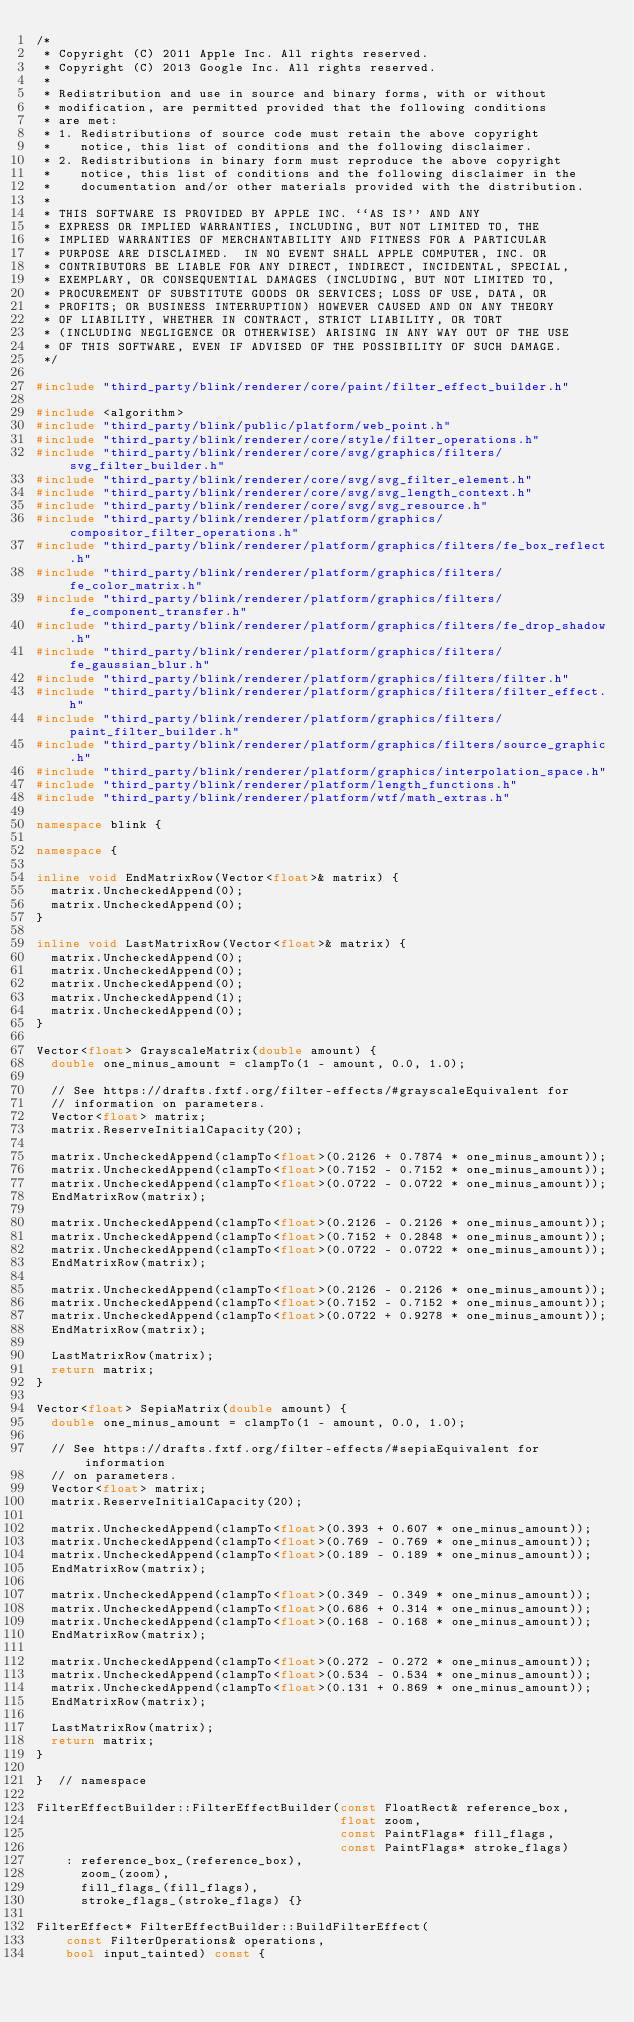<code> <loc_0><loc_0><loc_500><loc_500><_C++_>/*
 * Copyright (C) 2011 Apple Inc. All rights reserved.
 * Copyright (C) 2013 Google Inc. All rights reserved.
 *
 * Redistribution and use in source and binary forms, with or without
 * modification, are permitted provided that the following conditions
 * are met:
 * 1. Redistributions of source code must retain the above copyright
 *    notice, this list of conditions and the following disclaimer.
 * 2. Redistributions in binary form must reproduce the above copyright
 *    notice, this list of conditions and the following disclaimer in the
 *    documentation and/or other materials provided with the distribution.
 *
 * THIS SOFTWARE IS PROVIDED BY APPLE INC. ``AS IS'' AND ANY
 * EXPRESS OR IMPLIED WARRANTIES, INCLUDING, BUT NOT LIMITED TO, THE
 * IMPLIED WARRANTIES OF MERCHANTABILITY AND FITNESS FOR A PARTICULAR
 * PURPOSE ARE DISCLAIMED.  IN NO EVENT SHALL APPLE COMPUTER, INC. OR
 * CONTRIBUTORS BE LIABLE FOR ANY DIRECT, INDIRECT, INCIDENTAL, SPECIAL,
 * EXEMPLARY, OR CONSEQUENTIAL DAMAGES (INCLUDING, BUT NOT LIMITED TO,
 * PROCUREMENT OF SUBSTITUTE GOODS OR SERVICES; LOSS OF USE, DATA, OR
 * PROFITS; OR BUSINESS INTERRUPTION) HOWEVER CAUSED AND ON ANY THEORY
 * OF LIABILITY, WHETHER IN CONTRACT, STRICT LIABILITY, OR TORT
 * (INCLUDING NEGLIGENCE OR OTHERWISE) ARISING IN ANY WAY OUT OF THE USE
 * OF THIS SOFTWARE, EVEN IF ADVISED OF THE POSSIBILITY OF SUCH DAMAGE.
 */

#include "third_party/blink/renderer/core/paint/filter_effect_builder.h"

#include <algorithm>
#include "third_party/blink/public/platform/web_point.h"
#include "third_party/blink/renderer/core/style/filter_operations.h"
#include "third_party/blink/renderer/core/svg/graphics/filters/svg_filter_builder.h"
#include "third_party/blink/renderer/core/svg/svg_filter_element.h"
#include "third_party/blink/renderer/core/svg/svg_length_context.h"
#include "third_party/blink/renderer/core/svg/svg_resource.h"
#include "third_party/blink/renderer/platform/graphics/compositor_filter_operations.h"
#include "third_party/blink/renderer/platform/graphics/filters/fe_box_reflect.h"
#include "third_party/blink/renderer/platform/graphics/filters/fe_color_matrix.h"
#include "third_party/blink/renderer/platform/graphics/filters/fe_component_transfer.h"
#include "third_party/blink/renderer/platform/graphics/filters/fe_drop_shadow.h"
#include "third_party/blink/renderer/platform/graphics/filters/fe_gaussian_blur.h"
#include "third_party/blink/renderer/platform/graphics/filters/filter.h"
#include "third_party/blink/renderer/platform/graphics/filters/filter_effect.h"
#include "third_party/blink/renderer/platform/graphics/filters/paint_filter_builder.h"
#include "third_party/blink/renderer/platform/graphics/filters/source_graphic.h"
#include "third_party/blink/renderer/platform/graphics/interpolation_space.h"
#include "third_party/blink/renderer/platform/length_functions.h"
#include "third_party/blink/renderer/platform/wtf/math_extras.h"

namespace blink {

namespace {

inline void EndMatrixRow(Vector<float>& matrix) {
  matrix.UncheckedAppend(0);
  matrix.UncheckedAppend(0);
}

inline void LastMatrixRow(Vector<float>& matrix) {
  matrix.UncheckedAppend(0);
  matrix.UncheckedAppend(0);
  matrix.UncheckedAppend(0);
  matrix.UncheckedAppend(1);
  matrix.UncheckedAppend(0);
}

Vector<float> GrayscaleMatrix(double amount) {
  double one_minus_amount = clampTo(1 - amount, 0.0, 1.0);

  // See https://drafts.fxtf.org/filter-effects/#grayscaleEquivalent for
  // information on parameters.
  Vector<float> matrix;
  matrix.ReserveInitialCapacity(20);

  matrix.UncheckedAppend(clampTo<float>(0.2126 + 0.7874 * one_minus_amount));
  matrix.UncheckedAppend(clampTo<float>(0.7152 - 0.7152 * one_minus_amount));
  matrix.UncheckedAppend(clampTo<float>(0.0722 - 0.0722 * one_minus_amount));
  EndMatrixRow(matrix);

  matrix.UncheckedAppend(clampTo<float>(0.2126 - 0.2126 * one_minus_amount));
  matrix.UncheckedAppend(clampTo<float>(0.7152 + 0.2848 * one_minus_amount));
  matrix.UncheckedAppend(clampTo<float>(0.0722 - 0.0722 * one_minus_amount));
  EndMatrixRow(matrix);

  matrix.UncheckedAppend(clampTo<float>(0.2126 - 0.2126 * one_minus_amount));
  matrix.UncheckedAppend(clampTo<float>(0.7152 - 0.7152 * one_minus_amount));
  matrix.UncheckedAppend(clampTo<float>(0.0722 + 0.9278 * one_minus_amount));
  EndMatrixRow(matrix);

  LastMatrixRow(matrix);
  return matrix;
}

Vector<float> SepiaMatrix(double amount) {
  double one_minus_amount = clampTo(1 - amount, 0.0, 1.0);

  // See https://drafts.fxtf.org/filter-effects/#sepiaEquivalent for information
  // on parameters.
  Vector<float> matrix;
  matrix.ReserveInitialCapacity(20);

  matrix.UncheckedAppend(clampTo<float>(0.393 + 0.607 * one_minus_amount));
  matrix.UncheckedAppend(clampTo<float>(0.769 - 0.769 * one_minus_amount));
  matrix.UncheckedAppend(clampTo<float>(0.189 - 0.189 * one_minus_amount));
  EndMatrixRow(matrix);

  matrix.UncheckedAppend(clampTo<float>(0.349 - 0.349 * one_minus_amount));
  matrix.UncheckedAppend(clampTo<float>(0.686 + 0.314 * one_minus_amount));
  matrix.UncheckedAppend(clampTo<float>(0.168 - 0.168 * one_minus_amount));
  EndMatrixRow(matrix);

  matrix.UncheckedAppend(clampTo<float>(0.272 - 0.272 * one_minus_amount));
  matrix.UncheckedAppend(clampTo<float>(0.534 - 0.534 * one_minus_amount));
  matrix.UncheckedAppend(clampTo<float>(0.131 + 0.869 * one_minus_amount));
  EndMatrixRow(matrix);

  LastMatrixRow(matrix);
  return matrix;
}

}  // namespace

FilterEffectBuilder::FilterEffectBuilder(const FloatRect& reference_box,
                                         float zoom,
                                         const PaintFlags* fill_flags,
                                         const PaintFlags* stroke_flags)
    : reference_box_(reference_box),
      zoom_(zoom),
      fill_flags_(fill_flags),
      stroke_flags_(stroke_flags) {}

FilterEffect* FilterEffectBuilder::BuildFilterEffect(
    const FilterOperations& operations,
    bool input_tainted) const {</code> 